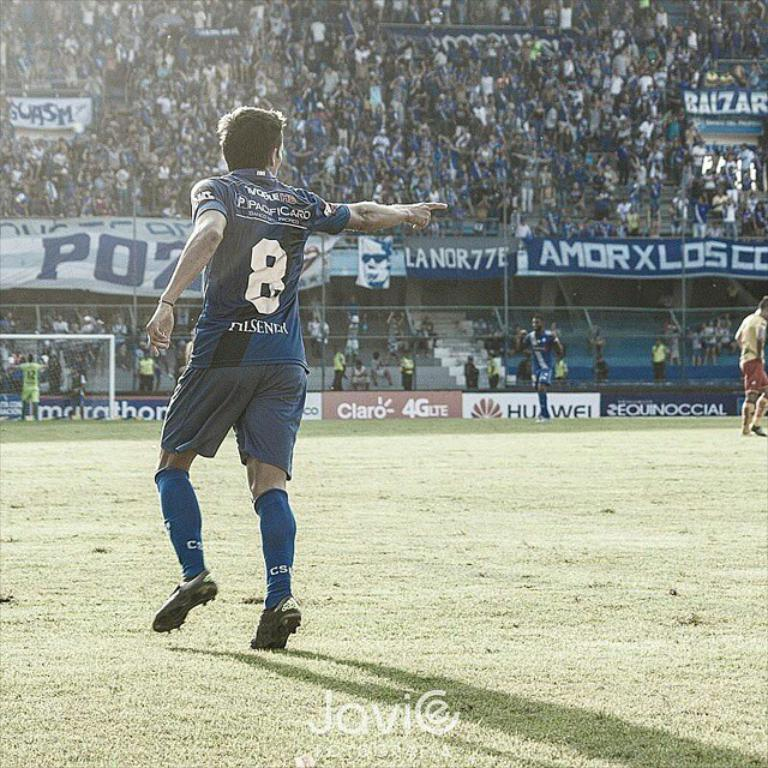Provide a one-sentence caption for the provided image. Player wearing number 8 pointing to something while on the field. 